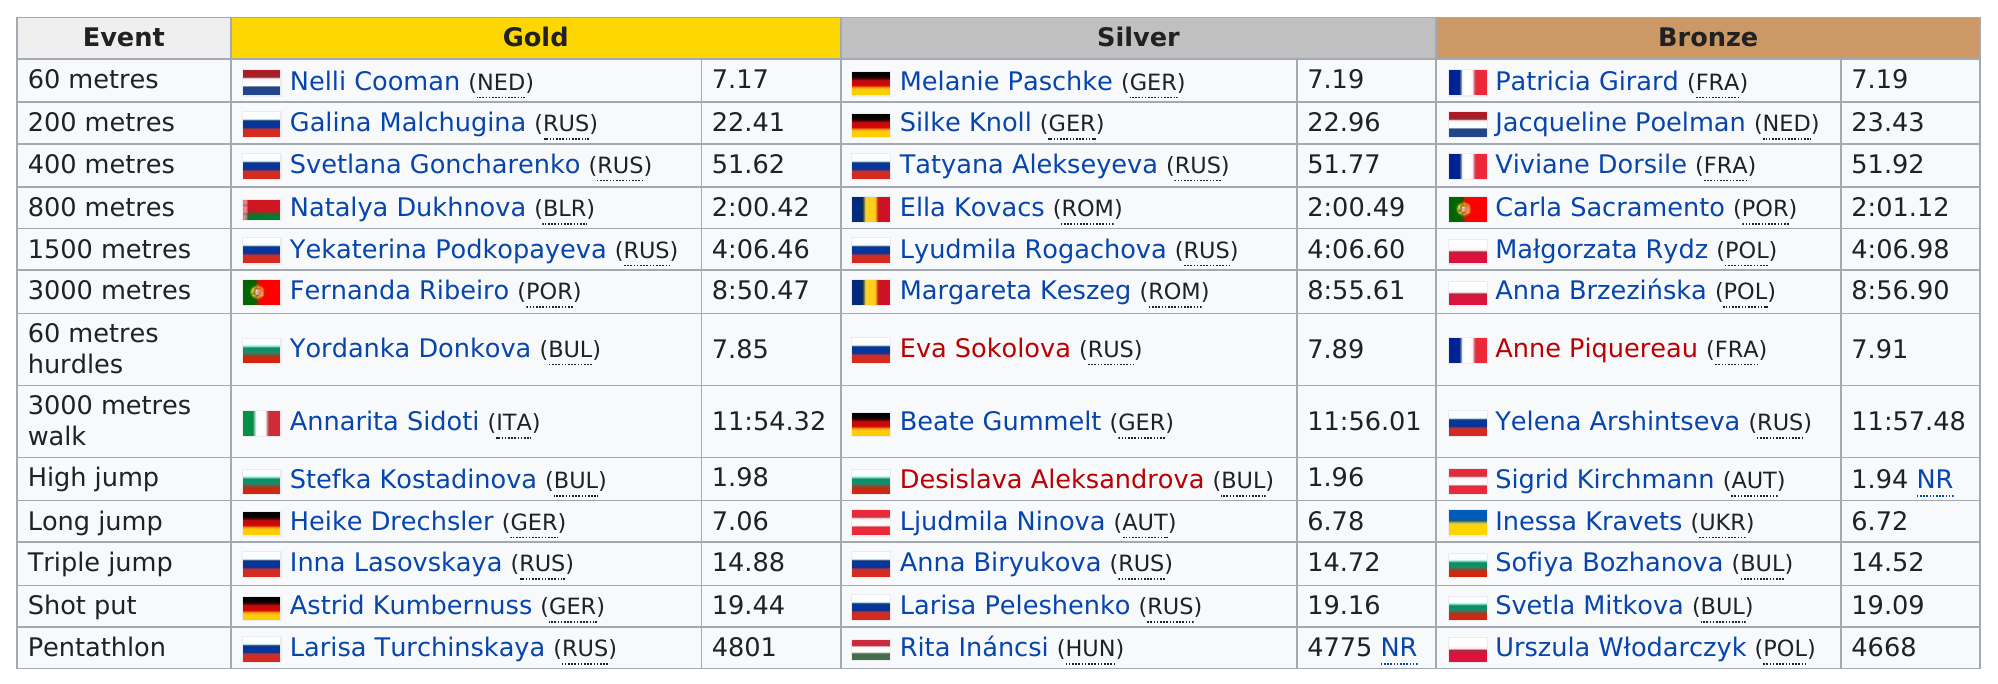Identify some key points in this picture. Five German women won medals at the event. 